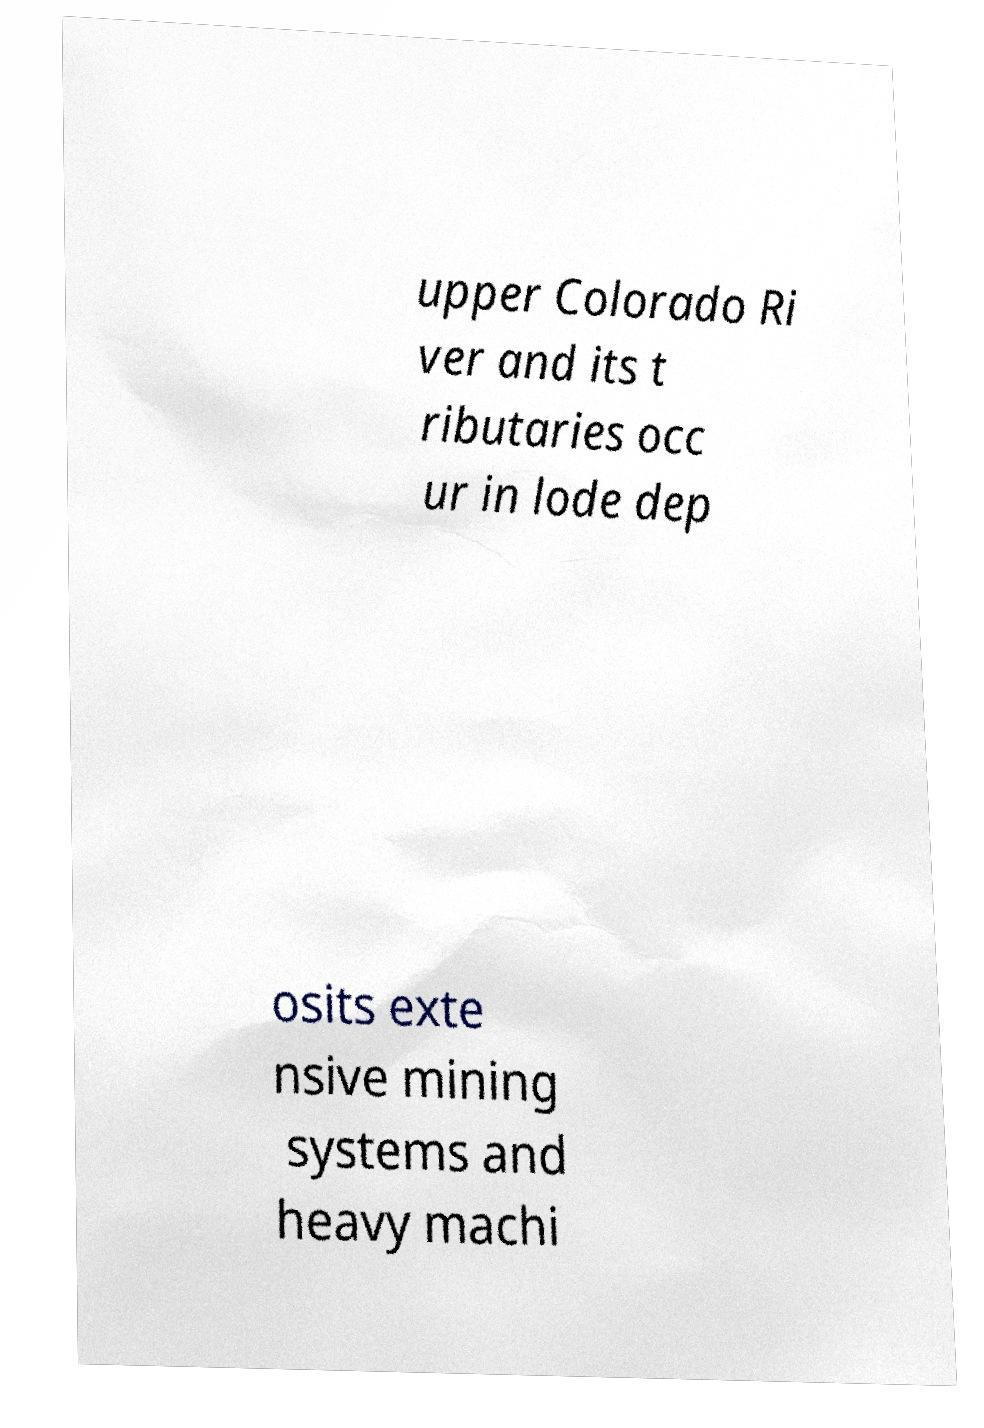Please read and relay the text visible in this image. What does it say? upper Colorado Ri ver and its t ributaries occ ur in lode dep osits exte nsive mining systems and heavy machi 